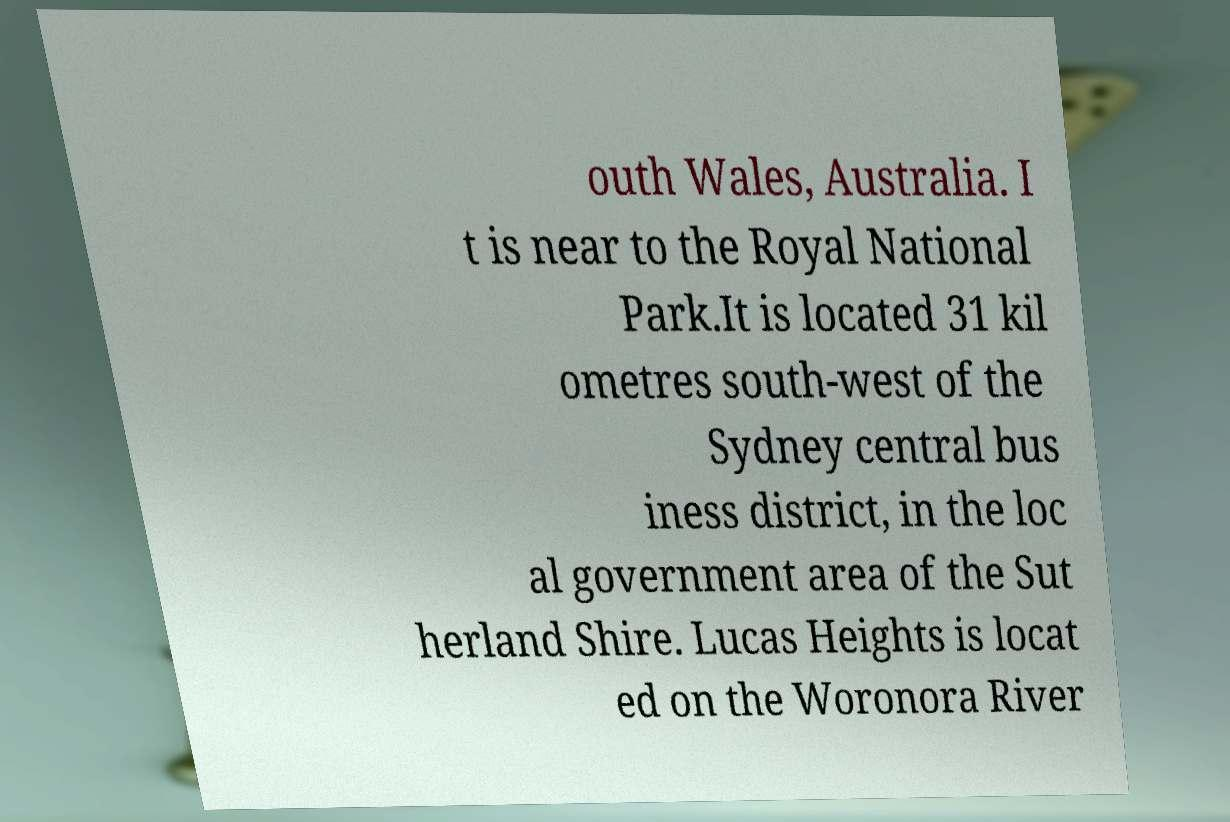There's text embedded in this image that I need extracted. Can you transcribe it verbatim? outh Wales, Australia. I t is near to the Royal National Park.It is located 31 kil ometres south-west of the Sydney central bus iness district, in the loc al government area of the Sut herland Shire. Lucas Heights is locat ed on the Woronora River 